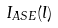Convert formula to latex. <formula><loc_0><loc_0><loc_500><loc_500>I _ { A S E } ( l )</formula> 